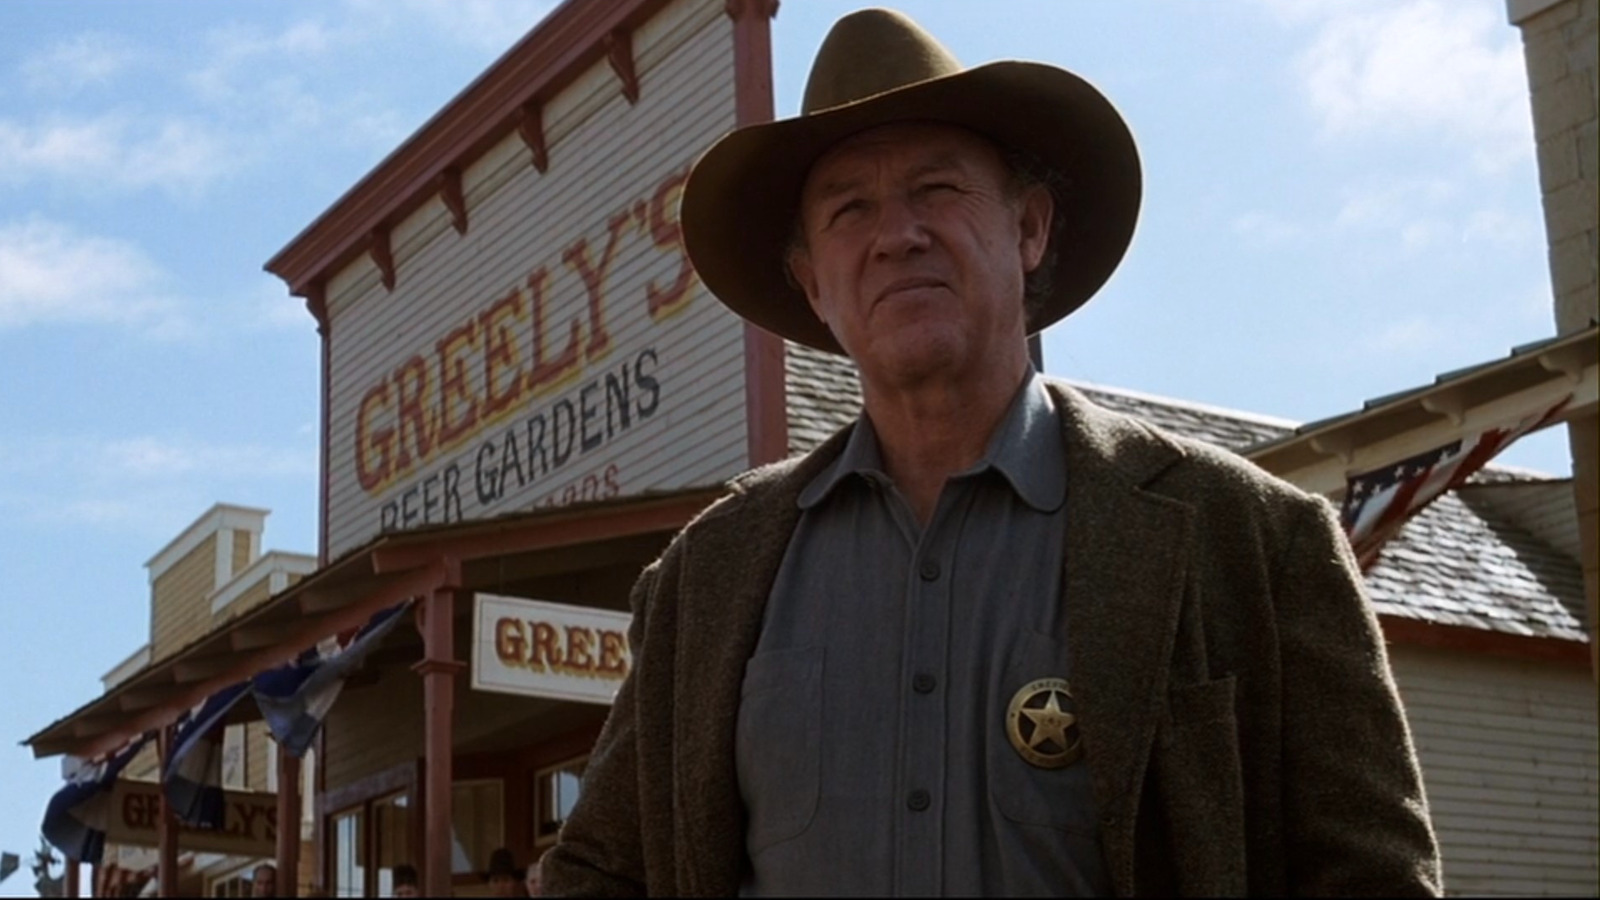What do you see happening in this image? In this image, a man dressed as a sheriff from the old west stands firmly in front of a building with a sign that reads 'Greeley's Beer Gardens.' He is wearing a brown cowboy hat, a gray jacket, and a gold badge on his left lapel. His serious expression and posture convey a sense of authority and readiness, capturing the essence of a classic western scene. 